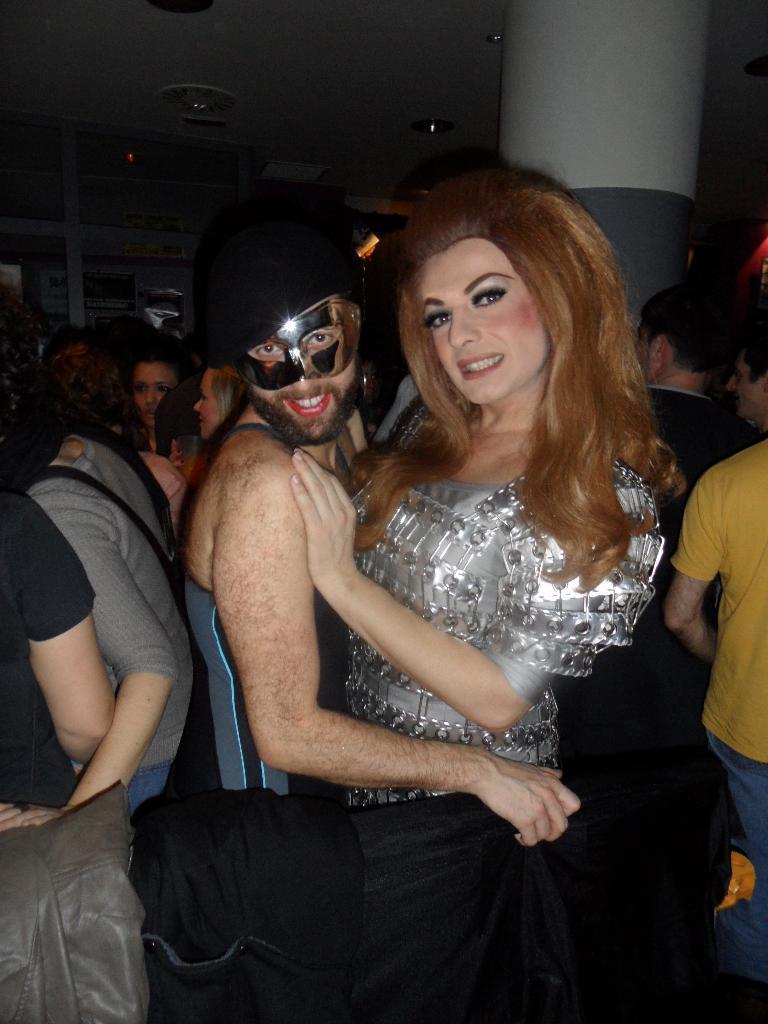In one or two sentences, can you explain what this image depicts? This picture shows the inner view of a room. There are some lights attached to the ceiling, some different objects are on the glass self, so many people are standing in the room and some objects are on the surface. 